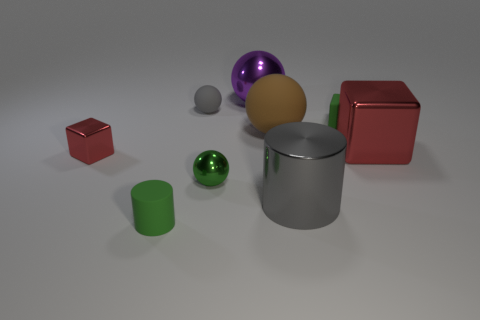Add 1 green blocks. How many objects exist? 10 Subtract all balls. How many objects are left? 5 Subtract 1 gray balls. How many objects are left? 8 Subtract all large objects. Subtract all large matte objects. How many objects are left? 4 Add 2 cubes. How many cubes are left? 5 Add 4 brown rubber spheres. How many brown rubber spheres exist? 5 